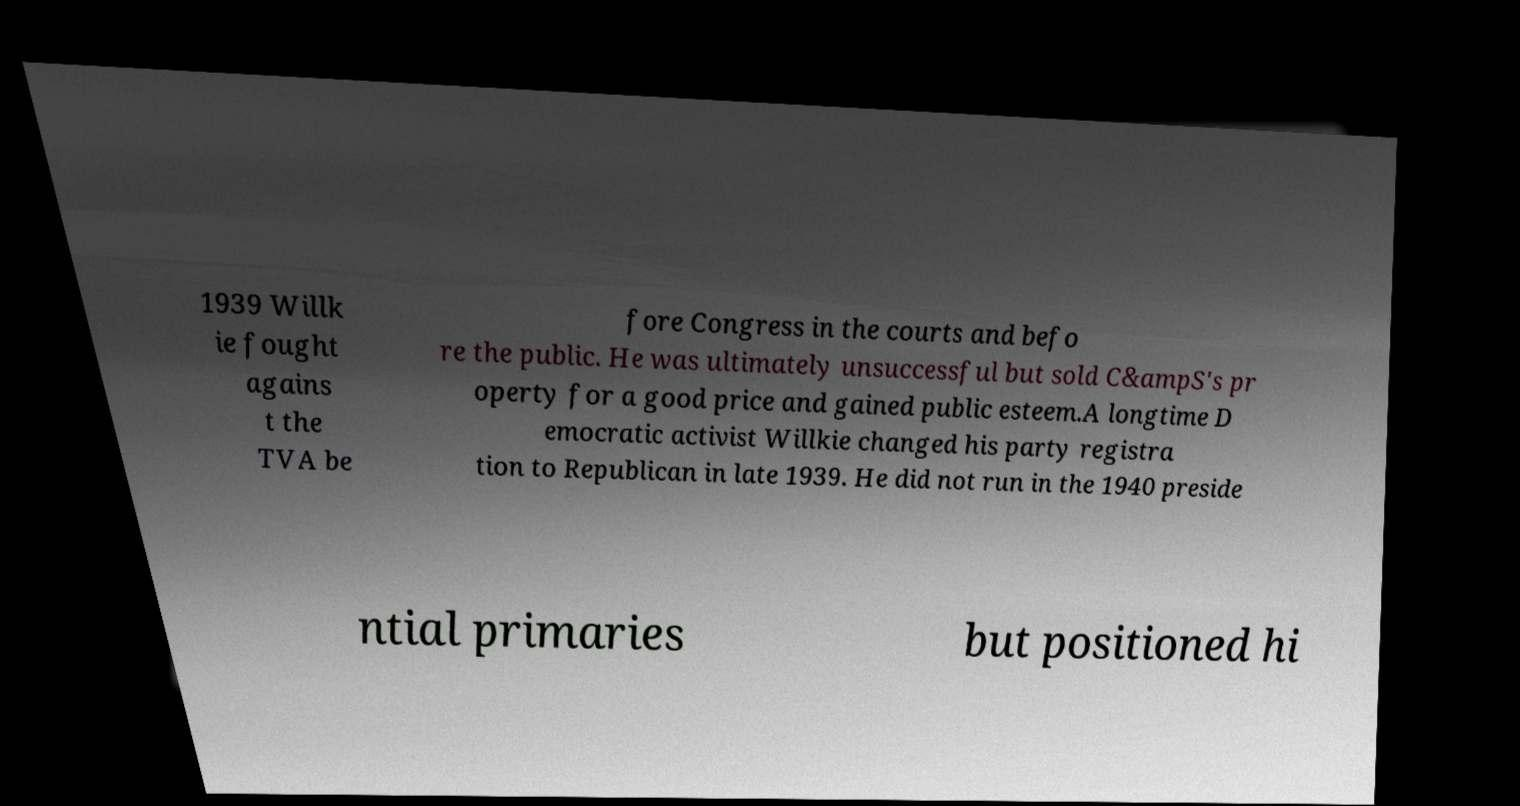What messages or text are displayed in this image? I need them in a readable, typed format. 1939 Willk ie fought agains t the TVA be fore Congress in the courts and befo re the public. He was ultimately unsuccessful but sold C&ampS's pr operty for a good price and gained public esteem.A longtime D emocratic activist Willkie changed his party registra tion to Republican in late 1939. He did not run in the 1940 preside ntial primaries but positioned hi 